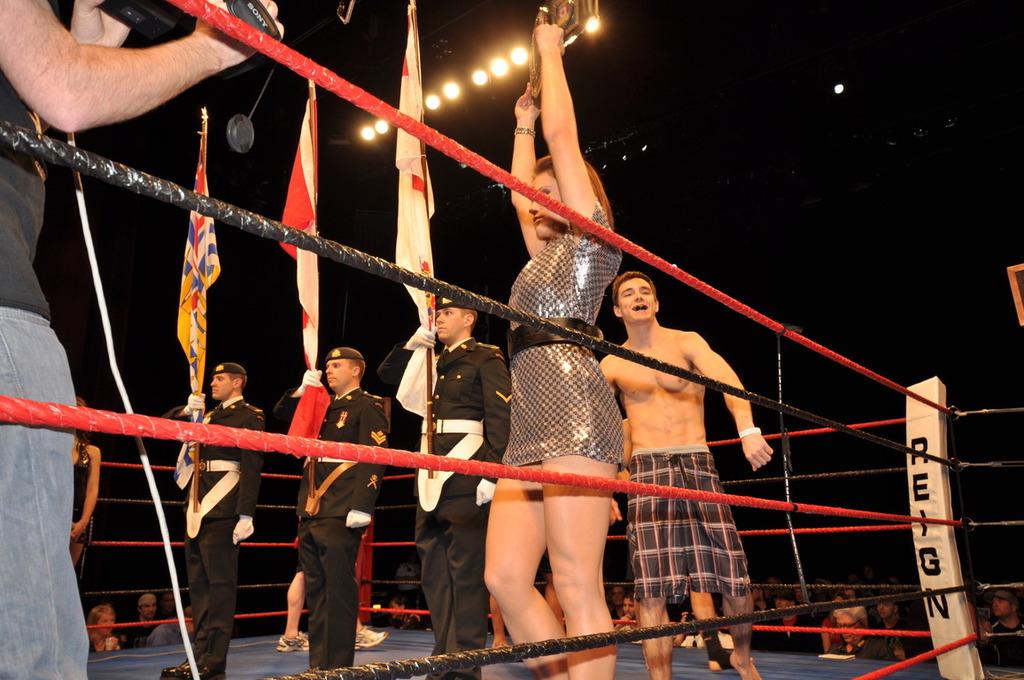What is the name of the player on the corner post?
Keep it short and to the point. Reign. 